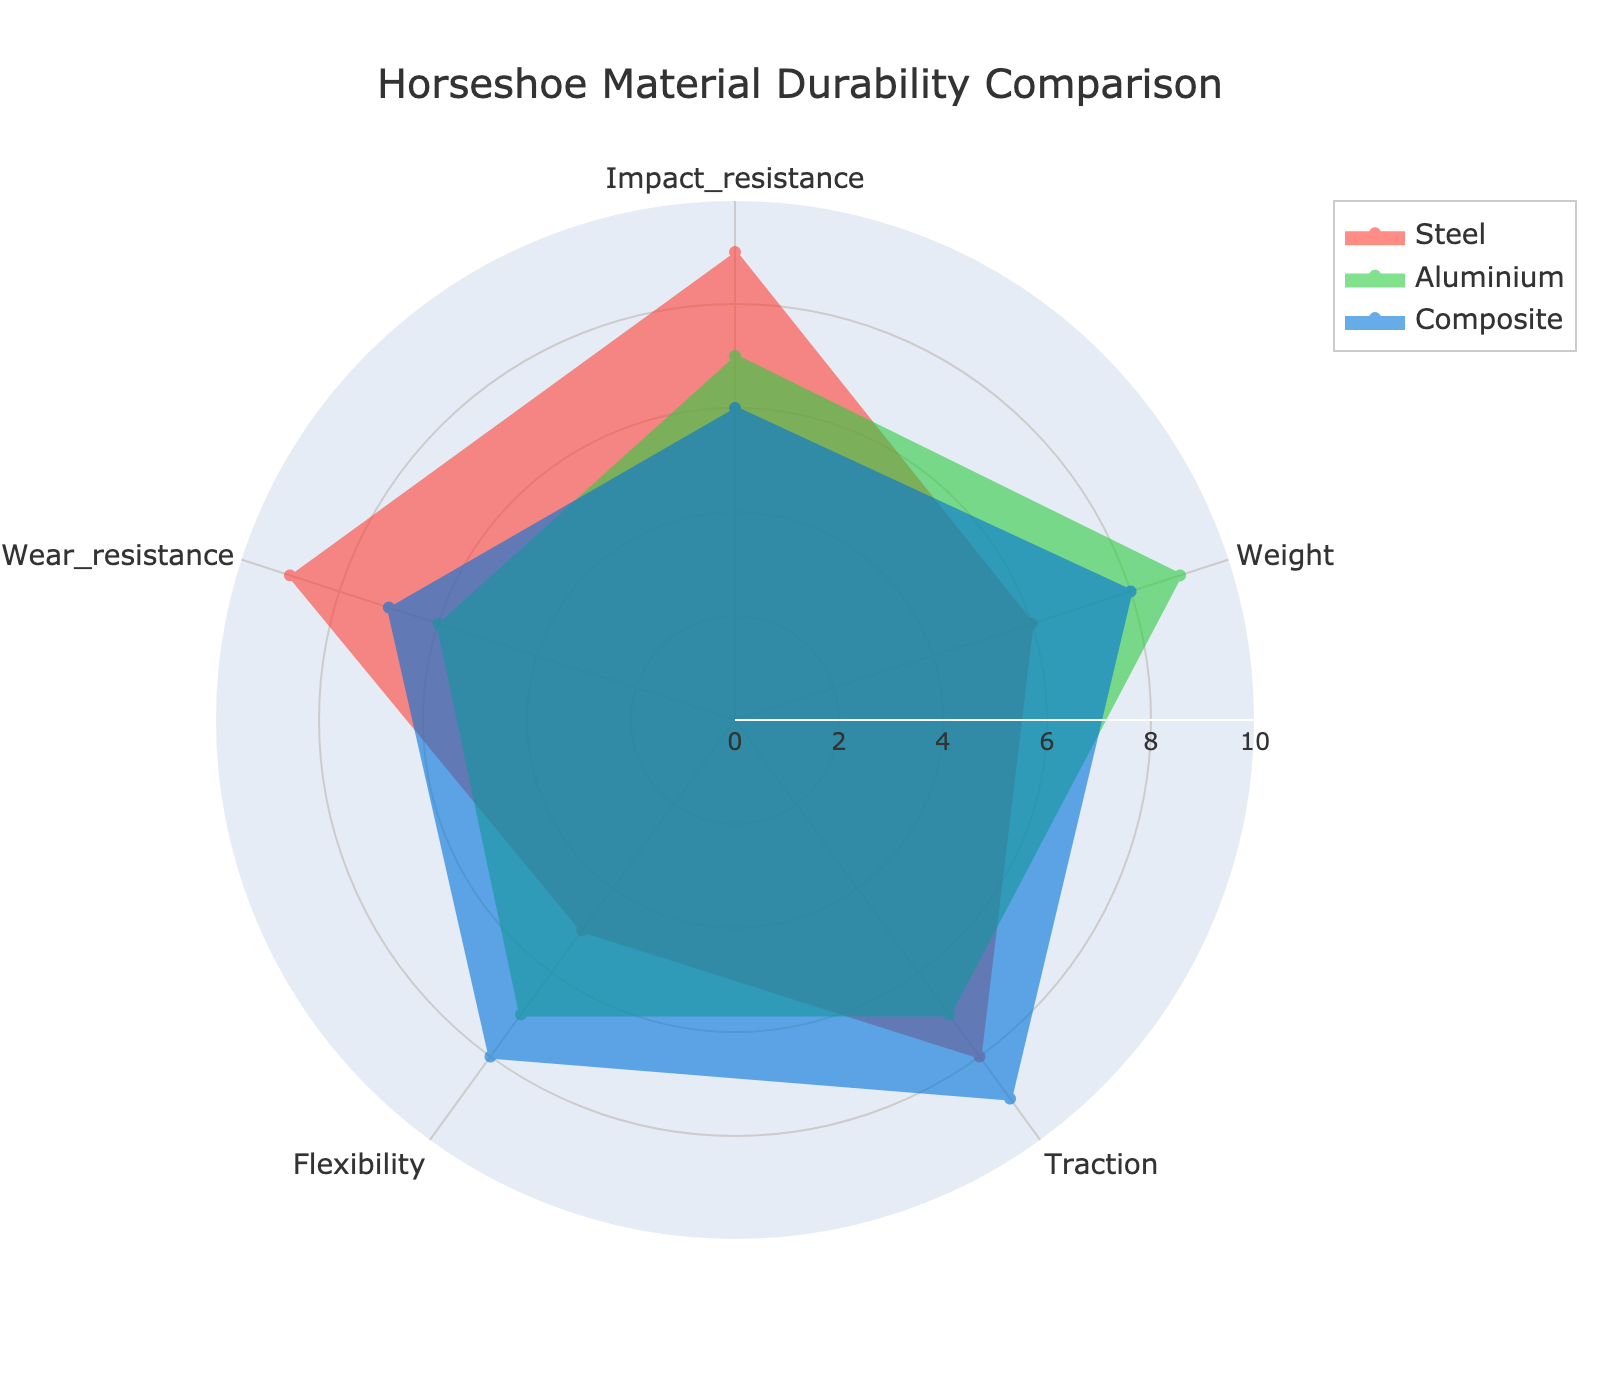What's the title of the radar chart? The title is located at the top center of the figure.
Answer: Horseshoe Material Durability Comparison Which material has the highest impact resistance? Look at the 'Impact resistance' values for each material on the radar chart and identify the highest value.
Answer: Steel Which material is the lightest by weight? Check the 'Weight' values on the radar chart, the highest value indicates the lightest material.
Answer: Aluminium Between Steel, Aluminium, and Composite, which has the best wear resistance? Compare the 'Wear resistance' values for all materials on the radar chart and identify the highest value.
Answer: Steel How many categories are being compared in the radar chart? Count the number of axes/categories displayed on the radar chart.
Answer: 5 What is the average traction value for all materials? Sum the 'Traction' values for all materials (8+7+9) and divide by the number of materials (3).
Answer: 8 Which material shows better flexibility than steel but worse than composite? Compare the 'Flexibility' values of all materials and find the one that is between the values of Steel and Composite.
Answer: Aluminium Which material outperforms the others in two or more categories? Evaluate each category and count the number of categories where each material has the highest value. Steel outperforms in 'Impact resistance' and 'Wear resistance'.
Answer: Steel If you were to choose a material solely based on a balance between weight and traction, which would be the best? Compare the 'Weight' and 'Traction' values for each material, looking for a good balance of high scores.
Answer: Aluminium What's the overall trend when considering the flexibility of the materials? Observe the 'Flexibility' values and note how they vary among the materials.
Answer: Composite > Aluminium > Steel 